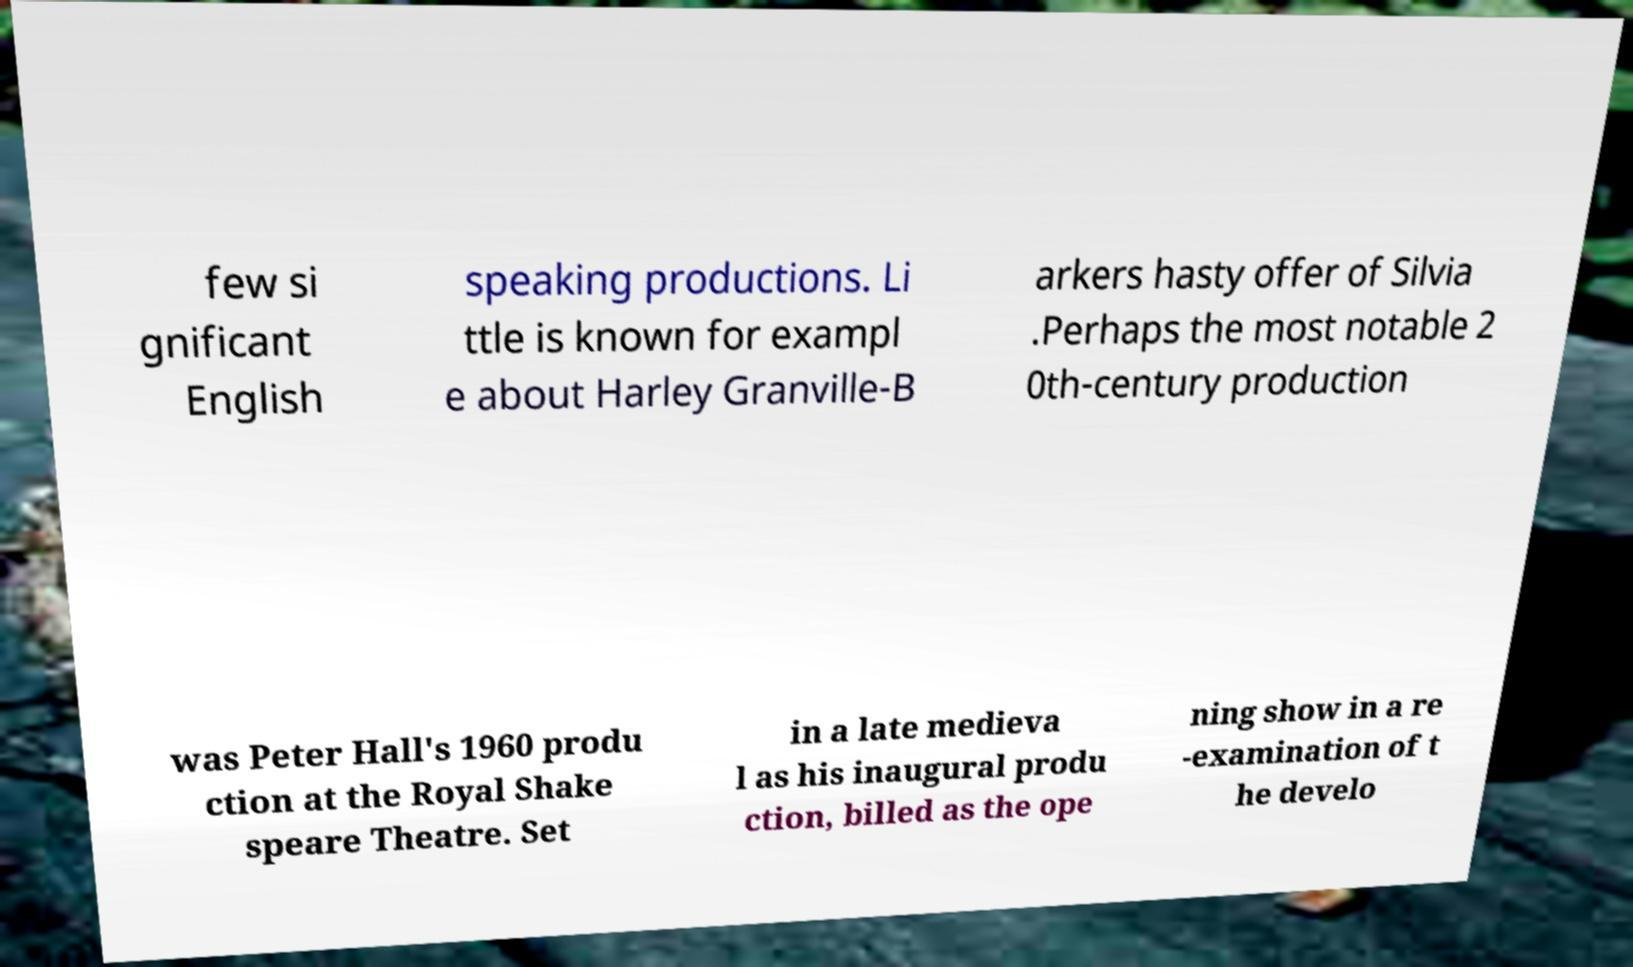There's text embedded in this image that I need extracted. Can you transcribe it verbatim? few si gnificant English speaking productions. Li ttle is known for exampl e about Harley Granville-B arkers hasty offer of Silvia .Perhaps the most notable 2 0th-century production was Peter Hall's 1960 produ ction at the Royal Shake speare Theatre. Set in a late medieva l as his inaugural produ ction, billed as the ope ning show in a re -examination of t he develo 